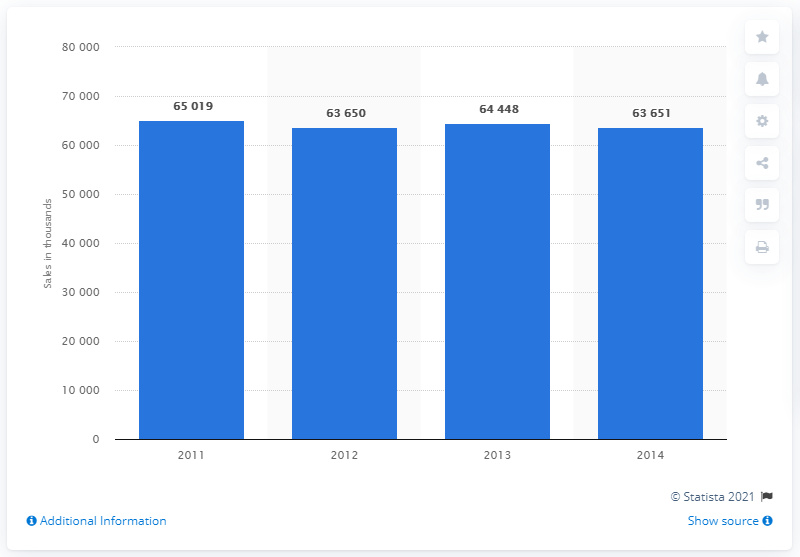List a handful of essential elements in this visual. According to estimates, in 2014 more than 63.65 million desktop computers were projected to be sold. 